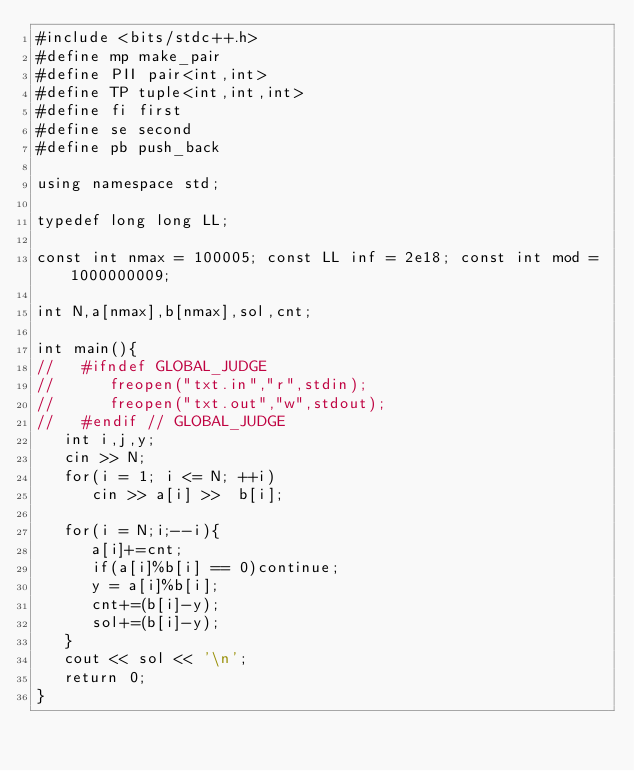<code> <loc_0><loc_0><loc_500><loc_500><_C++_>#include <bits/stdc++.h>
#define mp make_pair
#define PII pair<int,int>
#define TP tuple<int,int,int>
#define fi first
#define se second
#define pb push_back

using namespace std;

typedef long long LL;

const int nmax = 100005; const LL inf = 2e18; const int mod = 1000000009;

int N,a[nmax],b[nmax],sol,cnt;

int main(){
//   #ifndef GLOBAL_JUDGE
//      freopen("txt.in","r",stdin);
//      freopen("txt.out","w",stdout);
//   #endif // GLOBAL_JUDGE
   int i,j,y;
   cin >> N;
   for(i = 1; i <= N; ++i)
      cin >> a[i] >>  b[i];

   for(i = N;i;--i){
      a[i]+=cnt;
      if(a[i]%b[i] == 0)continue;
      y = a[i]%b[i];
      cnt+=(b[i]-y);
      sol+=(b[i]-y);
   }
   cout << sol << '\n';
   return 0;
}
</code> 